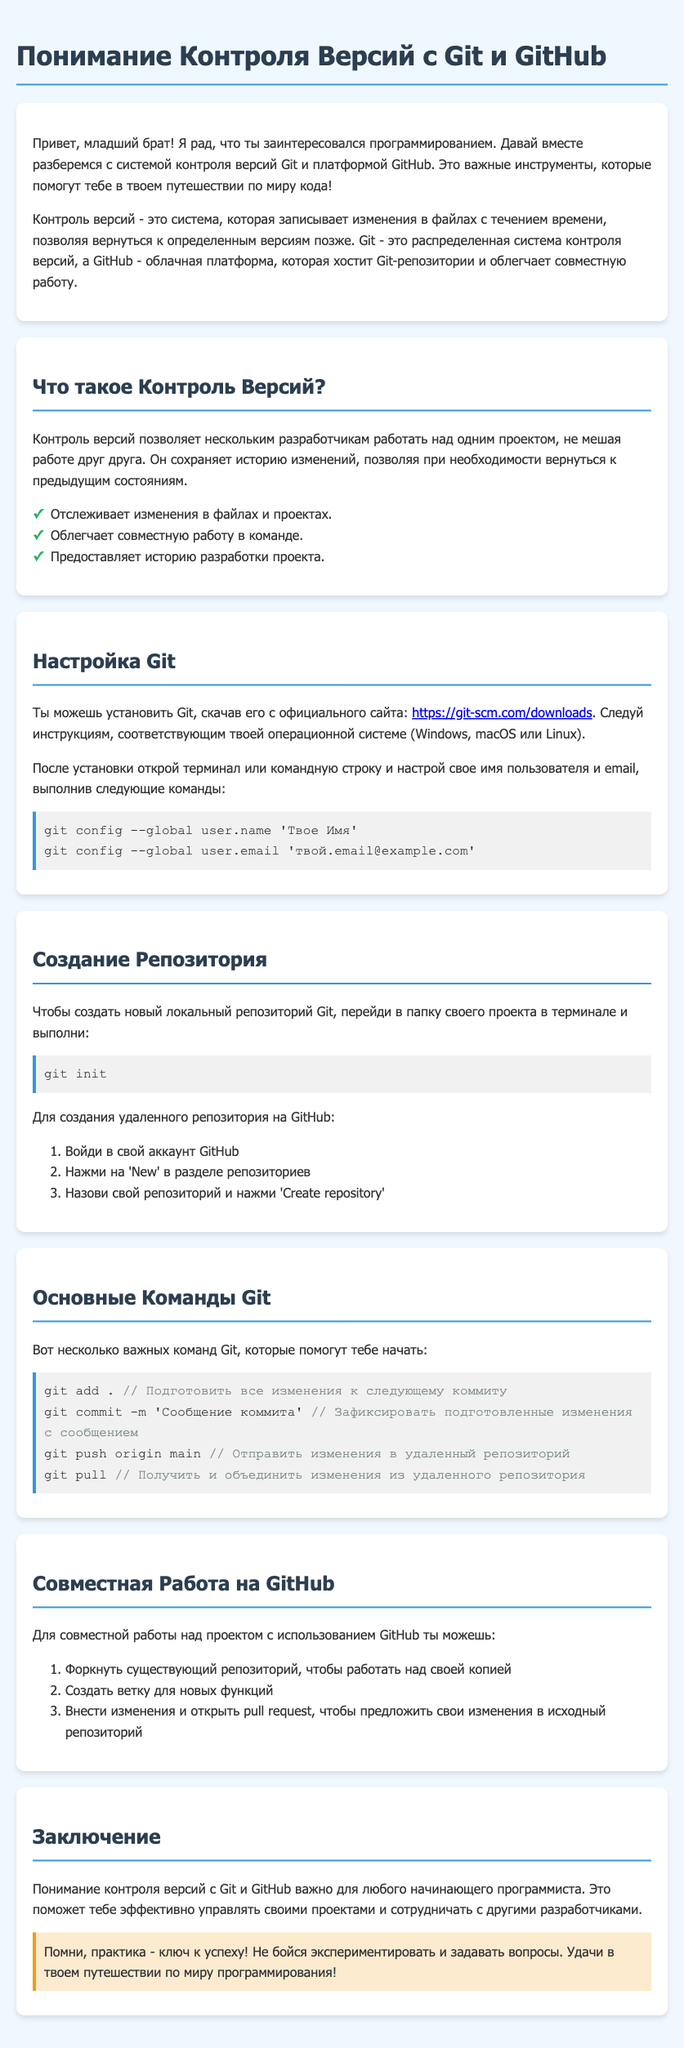Что такое контроль версий? В документе контроль версий описывается как система, которая записывает изменения в файлах с течением времени.
Answer: Система, которая записывает изменения в файлах с течением времени Как установить Git? Информация о том, как установить Git, представлена в разделе "Настройка Git", где говорится о скачивании с официального сайта.
Answer: Скачать с официального сайта Какие команды Git для первого использования? В разделе "Основные Команды Git" перечислены несколько команд, которые помогут начать работу с Git.
Answer: git add ., git commit, git push, git pull Что нужно сделать для создания репозитория на GitHub? В процессе создания репозитория на GitHub упоминаются три шага, которые нужно выполнить в своем аккаунте.
Answer: Войти в аккаунт, нажать 'New', создать репозиторий Какой цвет текста используется в примере команд Git? В документе для поясняющих комментариев к командам Git используется определенный цвет текста.
Answer: Серый Что такое pull request? В разделе "Совместная Работа на GitHub" описывается, что pull request — это предложение изменений в исходный репозиторий.
Answer: Предложение изменений в исходный репозиторий Какое значение имеет практика в изучении программирования? В заключении упоминается важность практики для успеха в программировании.
Answer: Ключ к успеху Сколько пунктов перечислено в разделе "Что такое Контроль Версий?" В разделе перечислены важные аспекты контроля версий в виде списка.
Answer: Три 